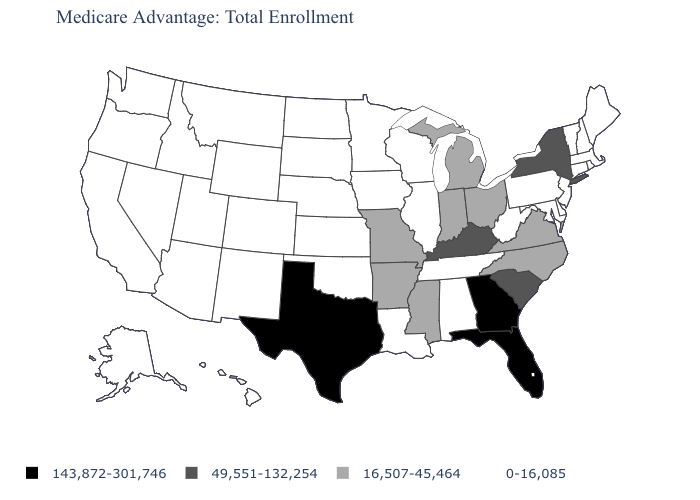Name the states that have a value in the range 143,872-301,746?
Quick response, please. Florida, Georgia, Texas. Name the states that have a value in the range 49,551-132,254?
Keep it brief. Kentucky, New York, South Carolina. Among the states that border South Carolina , which have the lowest value?
Give a very brief answer. North Carolina. What is the value of Alaska?
Concise answer only. 0-16,085. What is the value of New Hampshire?
Be succinct. 0-16,085. What is the highest value in states that border Oregon?
Quick response, please. 0-16,085. Which states have the lowest value in the USA?
Concise answer only. Alabama, Alaska, Arizona, California, Colorado, Connecticut, Delaware, Hawaii, Idaho, Illinois, Iowa, Kansas, Louisiana, Maine, Maryland, Massachusetts, Minnesota, Montana, Nebraska, Nevada, New Hampshire, New Jersey, New Mexico, North Dakota, Oklahoma, Oregon, Pennsylvania, Rhode Island, South Dakota, Tennessee, Utah, Vermont, Washington, West Virginia, Wisconsin, Wyoming. Does the first symbol in the legend represent the smallest category?
Keep it brief. No. Among the states that border Louisiana , does Mississippi have the highest value?
Answer briefly. No. What is the value of North Dakota?
Be succinct. 0-16,085. Among the states that border New York , which have the lowest value?
Write a very short answer. Connecticut, Massachusetts, New Jersey, Pennsylvania, Vermont. What is the highest value in the USA?
Keep it brief. 143,872-301,746. Does the first symbol in the legend represent the smallest category?
Answer briefly. No. 